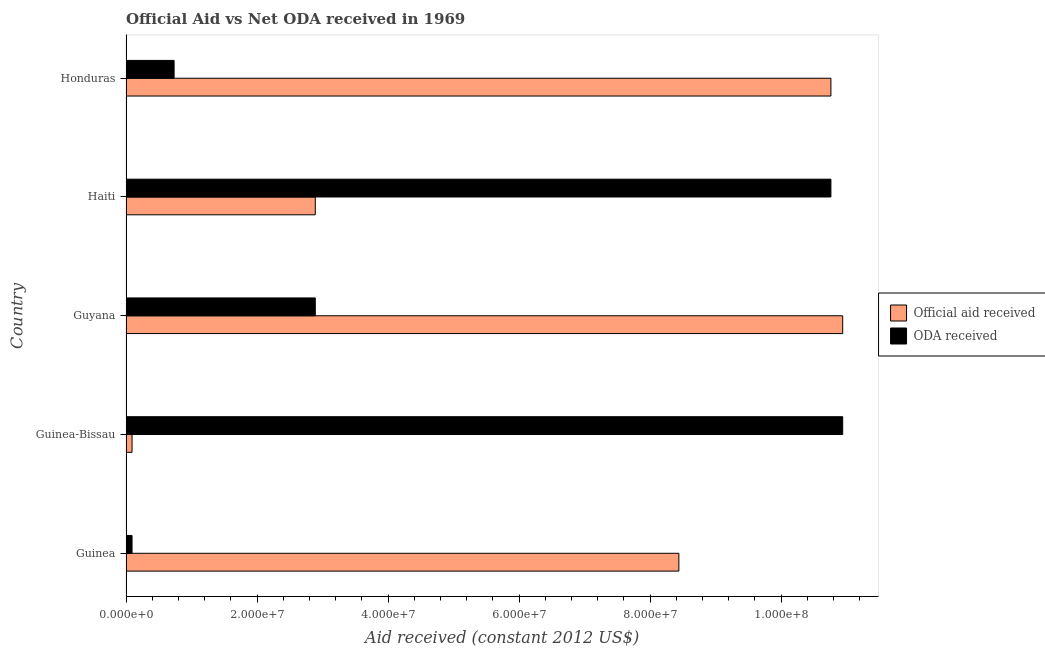How many different coloured bars are there?
Keep it short and to the point. 2. How many groups of bars are there?
Give a very brief answer. 5. Are the number of bars on each tick of the Y-axis equal?
Ensure brevity in your answer.  Yes. What is the label of the 3rd group of bars from the top?
Offer a terse response. Guyana. In how many cases, is the number of bars for a given country not equal to the number of legend labels?
Give a very brief answer. 0. What is the oda received in Guinea?
Offer a very short reply. 9.20e+05. Across all countries, what is the maximum oda received?
Offer a terse response. 1.09e+08. Across all countries, what is the minimum official aid received?
Your answer should be very brief. 9.20e+05. In which country was the official aid received maximum?
Ensure brevity in your answer.  Guyana. In which country was the oda received minimum?
Provide a short and direct response. Guinea. What is the total official aid received in the graph?
Keep it short and to the point. 3.31e+08. What is the difference between the oda received in Guyana and that in Haiti?
Offer a terse response. -7.87e+07. What is the difference between the oda received in Guyana and the official aid received in Guinea-Bissau?
Make the answer very short. 2.80e+07. What is the average official aid received per country?
Keep it short and to the point. 6.62e+07. What is the difference between the official aid received and oda received in Guinea?
Provide a short and direct response. 8.35e+07. What is the ratio of the official aid received in Haiti to that in Honduras?
Ensure brevity in your answer.  0.27. Is the difference between the official aid received in Guinea and Guinea-Bissau greater than the difference between the oda received in Guinea and Guinea-Bissau?
Provide a succinct answer. Yes. What is the difference between the highest and the second highest official aid received?
Ensure brevity in your answer.  1.80e+06. What is the difference between the highest and the lowest oda received?
Keep it short and to the point. 1.08e+08. What does the 2nd bar from the top in Honduras represents?
Provide a short and direct response. Official aid received. What does the 2nd bar from the bottom in Haiti represents?
Offer a terse response. ODA received. How many bars are there?
Give a very brief answer. 10. Are all the bars in the graph horizontal?
Offer a very short reply. Yes. How many countries are there in the graph?
Provide a short and direct response. 5. Where does the legend appear in the graph?
Ensure brevity in your answer.  Center right. How many legend labels are there?
Your answer should be very brief. 2. How are the legend labels stacked?
Ensure brevity in your answer.  Vertical. What is the title of the graph?
Offer a very short reply. Official Aid vs Net ODA received in 1969 . Does "Tetanus" appear as one of the legend labels in the graph?
Provide a succinct answer. No. What is the label or title of the X-axis?
Give a very brief answer. Aid received (constant 2012 US$). What is the Aid received (constant 2012 US$) of Official aid received in Guinea?
Provide a succinct answer. 8.44e+07. What is the Aid received (constant 2012 US$) in ODA received in Guinea?
Offer a very short reply. 9.20e+05. What is the Aid received (constant 2012 US$) in Official aid received in Guinea-Bissau?
Make the answer very short. 9.20e+05. What is the Aid received (constant 2012 US$) in ODA received in Guinea-Bissau?
Make the answer very short. 1.09e+08. What is the Aid received (constant 2012 US$) in Official aid received in Guyana?
Offer a very short reply. 1.09e+08. What is the Aid received (constant 2012 US$) of ODA received in Guyana?
Your answer should be compact. 2.89e+07. What is the Aid received (constant 2012 US$) in Official aid received in Haiti?
Offer a very short reply. 2.89e+07. What is the Aid received (constant 2012 US$) in ODA received in Haiti?
Offer a very short reply. 1.08e+08. What is the Aid received (constant 2012 US$) of Official aid received in Honduras?
Ensure brevity in your answer.  1.08e+08. What is the Aid received (constant 2012 US$) in ODA received in Honduras?
Your response must be concise. 7.34e+06. Across all countries, what is the maximum Aid received (constant 2012 US$) in Official aid received?
Give a very brief answer. 1.09e+08. Across all countries, what is the maximum Aid received (constant 2012 US$) of ODA received?
Your answer should be very brief. 1.09e+08. Across all countries, what is the minimum Aid received (constant 2012 US$) in Official aid received?
Your response must be concise. 9.20e+05. Across all countries, what is the minimum Aid received (constant 2012 US$) of ODA received?
Give a very brief answer. 9.20e+05. What is the total Aid received (constant 2012 US$) of Official aid received in the graph?
Give a very brief answer. 3.31e+08. What is the total Aid received (constant 2012 US$) of ODA received in the graph?
Give a very brief answer. 2.54e+08. What is the difference between the Aid received (constant 2012 US$) in Official aid received in Guinea and that in Guinea-Bissau?
Provide a succinct answer. 8.35e+07. What is the difference between the Aid received (constant 2012 US$) of ODA received in Guinea and that in Guinea-Bissau?
Give a very brief answer. -1.08e+08. What is the difference between the Aid received (constant 2012 US$) in Official aid received in Guinea and that in Guyana?
Your response must be concise. -2.50e+07. What is the difference between the Aid received (constant 2012 US$) of ODA received in Guinea and that in Guyana?
Give a very brief answer. -2.80e+07. What is the difference between the Aid received (constant 2012 US$) in Official aid received in Guinea and that in Haiti?
Offer a very short reply. 5.55e+07. What is the difference between the Aid received (constant 2012 US$) of ODA received in Guinea and that in Haiti?
Your answer should be compact. -1.07e+08. What is the difference between the Aid received (constant 2012 US$) of Official aid received in Guinea and that in Honduras?
Make the answer very short. -2.32e+07. What is the difference between the Aid received (constant 2012 US$) in ODA received in Guinea and that in Honduras?
Your answer should be very brief. -6.42e+06. What is the difference between the Aid received (constant 2012 US$) of Official aid received in Guinea-Bissau and that in Guyana?
Your answer should be compact. -1.08e+08. What is the difference between the Aid received (constant 2012 US$) in ODA received in Guinea-Bissau and that in Guyana?
Your answer should be compact. 8.05e+07. What is the difference between the Aid received (constant 2012 US$) in Official aid received in Guinea-Bissau and that in Haiti?
Keep it short and to the point. -2.80e+07. What is the difference between the Aid received (constant 2012 US$) in ODA received in Guinea-Bissau and that in Haiti?
Your response must be concise. 1.80e+06. What is the difference between the Aid received (constant 2012 US$) of Official aid received in Guinea-Bissau and that in Honduras?
Provide a succinct answer. -1.07e+08. What is the difference between the Aid received (constant 2012 US$) of ODA received in Guinea-Bissau and that in Honduras?
Your answer should be compact. 1.02e+08. What is the difference between the Aid received (constant 2012 US$) in Official aid received in Guyana and that in Haiti?
Offer a terse response. 8.05e+07. What is the difference between the Aid received (constant 2012 US$) in ODA received in Guyana and that in Haiti?
Your answer should be compact. -7.87e+07. What is the difference between the Aid received (constant 2012 US$) of Official aid received in Guyana and that in Honduras?
Give a very brief answer. 1.80e+06. What is the difference between the Aid received (constant 2012 US$) of ODA received in Guyana and that in Honduras?
Your answer should be compact. 2.16e+07. What is the difference between the Aid received (constant 2012 US$) of Official aid received in Haiti and that in Honduras?
Ensure brevity in your answer.  -7.87e+07. What is the difference between the Aid received (constant 2012 US$) of ODA received in Haiti and that in Honduras?
Your answer should be compact. 1.00e+08. What is the difference between the Aid received (constant 2012 US$) of Official aid received in Guinea and the Aid received (constant 2012 US$) of ODA received in Guinea-Bissau?
Provide a succinct answer. -2.50e+07. What is the difference between the Aid received (constant 2012 US$) of Official aid received in Guinea and the Aid received (constant 2012 US$) of ODA received in Guyana?
Offer a terse response. 5.55e+07. What is the difference between the Aid received (constant 2012 US$) of Official aid received in Guinea and the Aid received (constant 2012 US$) of ODA received in Haiti?
Make the answer very short. -2.32e+07. What is the difference between the Aid received (constant 2012 US$) in Official aid received in Guinea and the Aid received (constant 2012 US$) in ODA received in Honduras?
Offer a very short reply. 7.70e+07. What is the difference between the Aid received (constant 2012 US$) of Official aid received in Guinea-Bissau and the Aid received (constant 2012 US$) of ODA received in Guyana?
Keep it short and to the point. -2.80e+07. What is the difference between the Aid received (constant 2012 US$) in Official aid received in Guinea-Bissau and the Aid received (constant 2012 US$) in ODA received in Haiti?
Provide a succinct answer. -1.07e+08. What is the difference between the Aid received (constant 2012 US$) of Official aid received in Guinea-Bissau and the Aid received (constant 2012 US$) of ODA received in Honduras?
Ensure brevity in your answer.  -6.42e+06. What is the difference between the Aid received (constant 2012 US$) in Official aid received in Guyana and the Aid received (constant 2012 US$) in ODA received in Haiti?
Provide a short and direct response. 1.80e+06. What is the difference between the Aid received (constant 2012 US$) in Official aid received in Guyana and the Aid received (constant 2012 US$) in ODA received in Honduras?
Keep it short and to the point. 1.02e+08. What is the difference between the Aid received (constant 2012 US$) in Official aid received in Haiti and the Aid received (constant 2012 US$) in ODA received in Honduras?
Give a very brief answer. 2.16e+07. What is the average Aid received (constant 2012 US$) in Official aid received per country?
Make the answer very short. 6.62e+07. What is the average Aid received (constant 2012 US$) of ODA received per country?
Your answer should be very brief. 5.08e+07. What is the difference between the Aid received (constant 2012 US$) in Official aid received and Aid received (constant 2012 US$) in ODA received in Guinea?
Your answer should be very brief. 8.35e+07. What is the difference between the Aid received (constant 2012 US$) of Official aid received and Aid received (constant 2012 US$) of ODA received in Guinea-Bissau?
Make the answer very short. -1.08e+08. What is the difference between the Aid received (constant 2012 US$) in Official aid received and Aid received (constant 2012 US$) in ODA received in Guyana?
Provide a succinct answer. 8.05e+07. What is the difference between the Aid received (constant 2012 US$) in Official aid received and Aid received (constant 2012 US$) in ODA received in Haiti?
Provide a short and direct response. -7.87e+07. What is the difference between the Aid received (constant 2012 US$) of Official aid received and Aid received (constant 2012 US$) of ODA received in Honduras?
Offer a terse response. 1.00e+08. What is the ratio of the Aid received (constant 2012 US$) in Official aid received in Guinea to that in Guinea-Bissau?
Keep it short and to the point. 91.73. What is the ratio of the Aid received (constant 2012 US$) in ODA received in Guinea to that in Guinea-Bissau?
Offer a terse response. 0.01. What is the ratio of the Aid received (constant 2012 US$) in Official aid received in Guinea to that in Guyana?
Give a very brief answer. 0.77. What is the ratio of the Aid received (constant 2012 US$) in ODA received in Guinea to that in Guyana?
Provide a succinct answer. 0.03. What is the ratio of the Aid received (constant 2012 US$) of Official aid received in Guinea to that in Haiti?
Give a very brief answer. 2.92. What is the ratio of the Aid received (constant 2012 US$) of ODA received in Guinea to that in Haiti?
Your response must be concise. 0.01. What is the ratio of the Aid received (constant 2012 US$) in Official aid received in Guinea to that in Honduras?
Offer a very short reply. 0.78. What is the ratio of the Aid received (constant 2012 US$) of ODA received in Guinea to that in Honduras?
Give a very brief answer. 0.13. What is the ratio of the Aid received (constant 2012 US$) of Official aid received in Guinea-Bissau to that in Guyana?
Provide a succinct answer. 0.01. What is the ratio of the Aid received (constant 2012 US$) in ODA received in Guinea-Bissau to that in Guyana?
Give a very brief answer. 3.79. What is the ratio of the Aid received (constant 2012 US$) of Official aid received in Guinea-Bissau to that in Haiti?
Provide a succinct answer. 0.03. What is the ratio of the Aid received (constant 2012 US$) of ODA received in Guinea-Bissau to that in Haiti?
Your response must be concise. 1.02. What is the ratio of the Aid received (constant 2012 US$) of Official aid received in Guinea-Bissau to that in Honduras?
Keep it short and to the point. 0.01. What is the ratio of the Aid received (constant 2012 US$) in ODA received in Guinea-Bissau to that in Honduras?
Provide a succinct answer. 14.9. What is the ratio of the Aid received (constant 2012 US$) of Official aid received in Guyana to that in Haiti?
Your answer should be very brief. 3.79. What is the ratio of the Aid received (constant 2012 US$) of ODA received in Guyana to that in Haiti?
Offer a very short reply. 0.27. What is the ratio of the Aid received (constant 2012 US$) in Official aid received in Guyana to that in Honduras?
Your answer should be compact. 1.02. What is the ratio of the Aid received (constant 2012 US$) of ODA received in Guyana to that in Honduras?
Provide a succinct answer. 3.94. What is the ratio of the Aid received (constant 2012 US$) of Official aid received in Haiti to that in Honduras?
Provide a short and direct response. 0.27. What is the ratio of the Aid received (constant 2012 US$) in ODA received in Haiti to that in Honduras?
Offer a terse response. 14.66. What is the difference between the highest and the second highest Aid received (constant 2012 US$) of Official aid received?
Offer a terse response. 1.80e+06. What is the difference between the highest and the second highest Aid received (constant 2012 US$) of ODA received?
Provide a succinct answer. 1.80e+06. What is the difference between the highest and the lowest Aid received (constant 2012 US$) of Official aid received?
Your response must be concise. 1.08e+08. What is the difference between the highest and the lowest Aid received (constant 2012 US$) of ODA received?
Make the answer very short. 1.08e+08. 